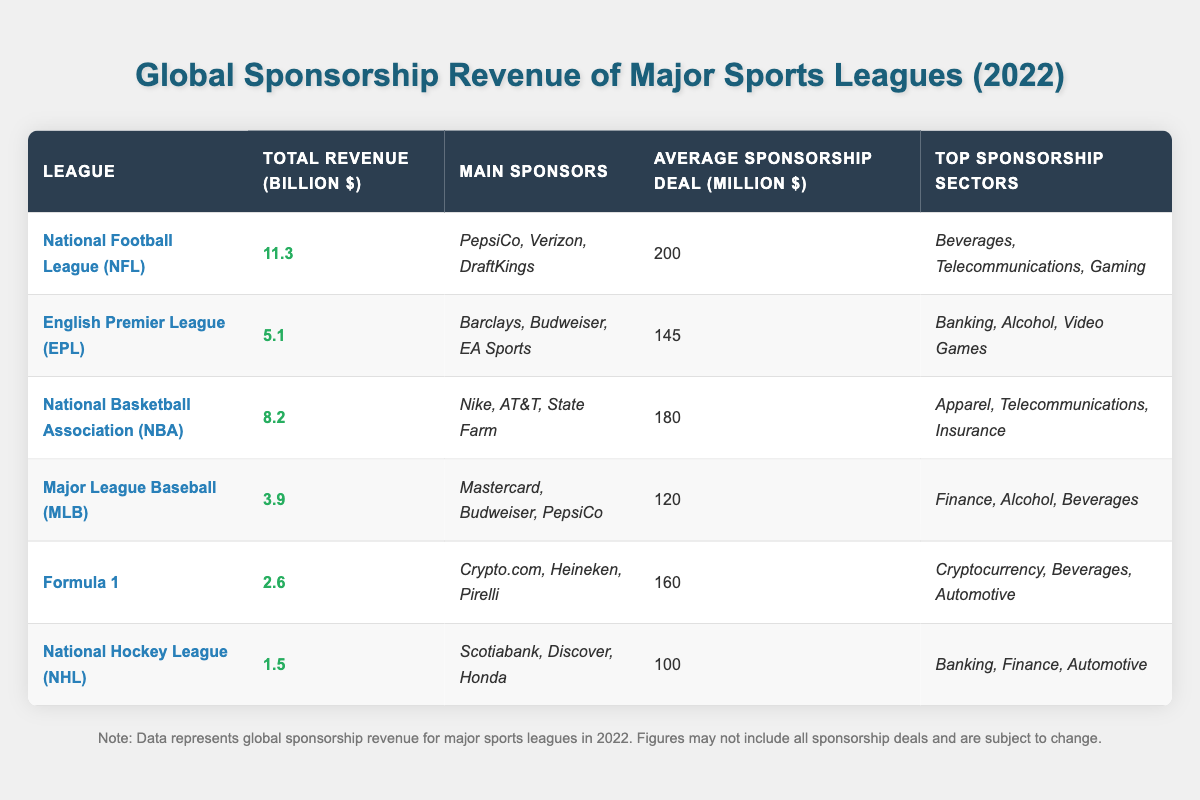What is the total sponsorship revenue of the National Football League (NFL) in 2022? The table shows that the total revenue for the NFL is listed as 11.3 billion dollars for the year 2022.
Answer: 11.3 billion dollars Which league has the highest average sponsorship deal? The average sponsorship deal for the NFL is 200 million dollars, while the other leagues have lower averages: NBA (180), EPL (145), MLB (120), F1 (160), and NHL (100). Thus, NFL has the highest.
Answer: National Football League (NFL) How much revenue does Formula 1 generate compared to the National Hockey League (NHL)? Formula 1's total revenue is 2.6 billion dollars, while the NHL generates 1.5 billion dollars. The difference in revenue is 2.6 - 1.5 = 1.1 billion dollars, indicating that F1 generates more.
Answer: Formula 1 generates 1.1 billion dollars more What are the top sponsorship sectors for the English Premier League (EPL)? According to the table, the top sponsorship sectors for EPL are Banking, Alcohol, and Video Games.
Answer: Banking, Alcohol, Video Games Does the National Basketball Association (NBA) have any main sponsors that are also sponsors of the Major League Baseball (MLB)? The main sponsors for the NBA are Nike, AT&T, and State Farm, while the MLB lists Mastercard, Budweiser, and PepsiCo as its sponsors. PepsiCo is a common sponsor.
Answer: Yes What is the combined total revenue of the top three leagues: NFL, NBA, and EPL? The total revenue for NFL is 11.3 billion, NBA is 8.2 billion, and EPL is 5.1 billion. Adding these amounts gives: 11.3 + 8.2 + 5.1 = 24.6 billion dollars combined.
Answer: 24.6 billion dollars How many leagues have total revenues above 5 billion dollars? The leagues with revenues above 5 billion include NFL (11.3), NBA (8.2), and EPL (5.1). Thus, there are three leagues above that threshold.
Answer: Three leagues Which league has the lowest total sponsorship revenue and what is the amount? The NHL has the lowest total revenue listed in the table at 1.5 billion dollars.
Answer: National Hockey League (NHL) at 1.5 billion dollars What percentage of the total revenue does the NFL represent compared to the combined revenue of all leagues listed? The total revenue from all leagues is 11.3 + 5.1 + 8.2 + 3.9 + 2.6 + 1.5 = 32.6 billion. The NFL's revenue (11.3) as a percentage of total is (11.3 / 32.6) x 100 ≈ 34.66%.
Answer: Approximately 34.66% Based on total revenue, is the NBA or the EPL closer in revenue to the MLB? The NBA has a total revenue of 8.2 billion and the EPL has 5.1 billion, while the MLB has 3.9 billion. The difference from MLB for NBA is 8.2 - 3.9 = 4.3 billion, and for EPL is 5.1 - 3.9 = 1.2 billion. The EPL is closer to MLB by 1.2 billion.
Answer: English Premier League (EPL) 